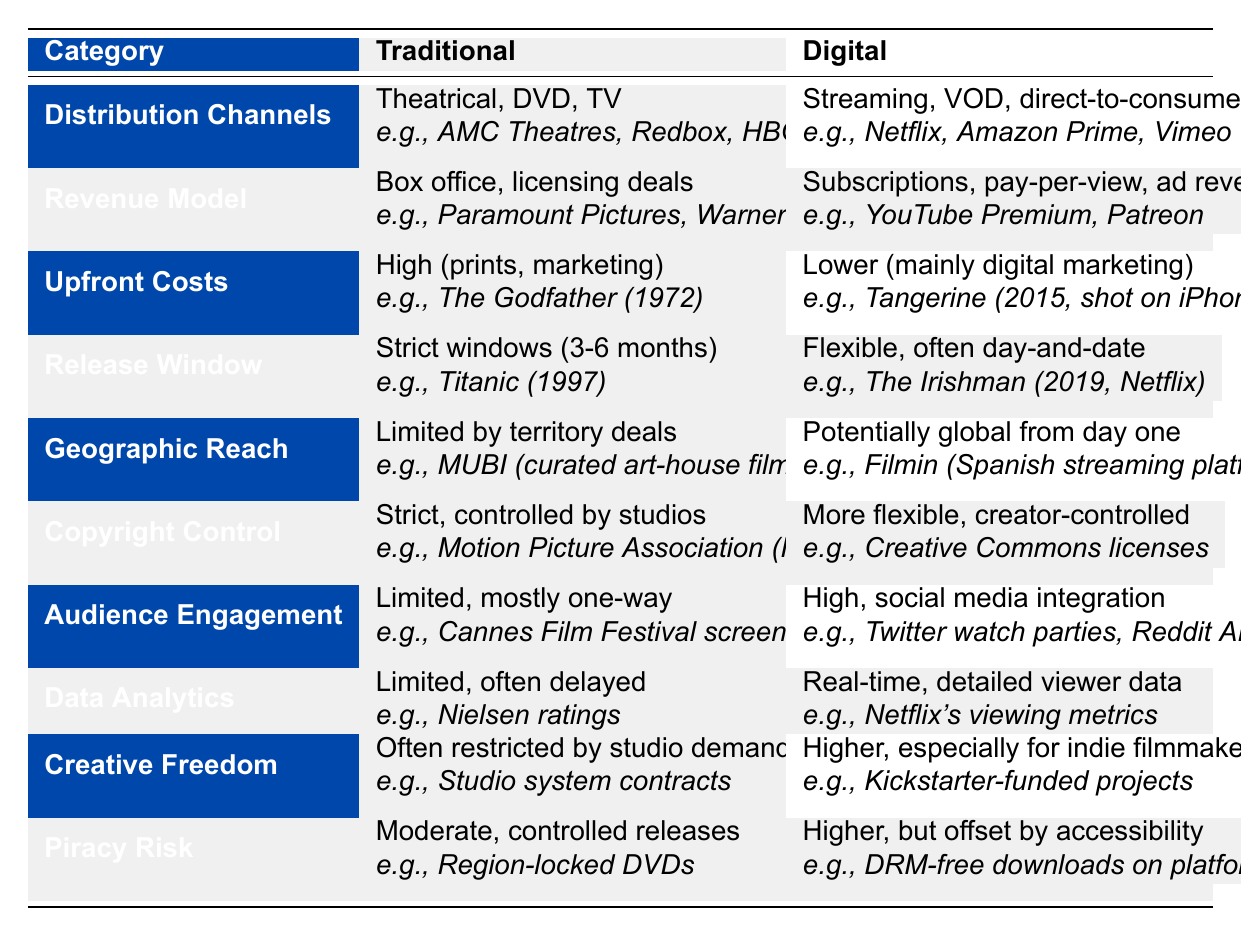What are the distribution channels for traditional film distribution? The table specifies that traditional film distribution uses "Theatrical, DVD, TV," and provides examples like "AMC Theatres, Redbox, HBO."
Answer: Theatrical, DVD, TV Which revenue model is associated with digital distribution? According to the table, the digital revenue model includes "Subscriptions, pay-per-view, ad revenue," with examples like "YouTube Premium, Patreon."
Answer: Subscriptions, pay-per-view, ad revenue Is copyright control more flexible in digital distribution compared to traditional distribution? The table states that traditional distribution has "Strict, controlled by studios," while digital has "More flexible, creator-controlled." Thus, digital distribution is indeed more flexible.
Answer: Yes What is the difference in upfront costs between traditional and digital distribution? Traditional distribution is characterized by "High (prints, marketing)" while digital distribution has "Lower (mainly digital marketing)." This indicates a significant difference in upfront costs.
Answer: High vs. Lower In which distribution model is audience engagement higher? The table indicates "Limited, mostly one-way" for traditional audience engagement and "High, social media integration" for digital, meaning audience engagement is higher in digital distribution.
Answer: Digital What is the release window duration for traditional films? Traditional films have "Strict windows (3-6 months)" as per the table.
Answer: Strict windows (3-6 months) Compare the geographic reach of traditional and digital distribution. Traditional distribution has "Limited by territory deals," while digital can be "Potentially global from day one," indicating that digital has a much broader reach.
Answer: Limited vs. Potentially global How do piracy risks compare for traditional versus digital distribution? The table states that traditional distribution has "Moderate, controlled releases" while digital has "Higher, but offset by accessibility." This means digital distribution carries a higher piracy risk.
Answer: Higher What can be said about the real-time data analytics capability between the two distribution models? The table shows that traditional distribution offers "Limited, often delayed," while digital offers "Real-time, detailed viewer data." Therefore, digital has a clear advantage in data analytics capabilities.
Answer: Digital has an advantage Is creative freedom greater for filmmakers in the digital distribution model than in traditional? The table indicates "Often restricted by studio demands" for traditional and "Higher, especially for indie filmmakers" for digital, confirming that creative freedom is greater in digital distribution.
Answer: Yes 